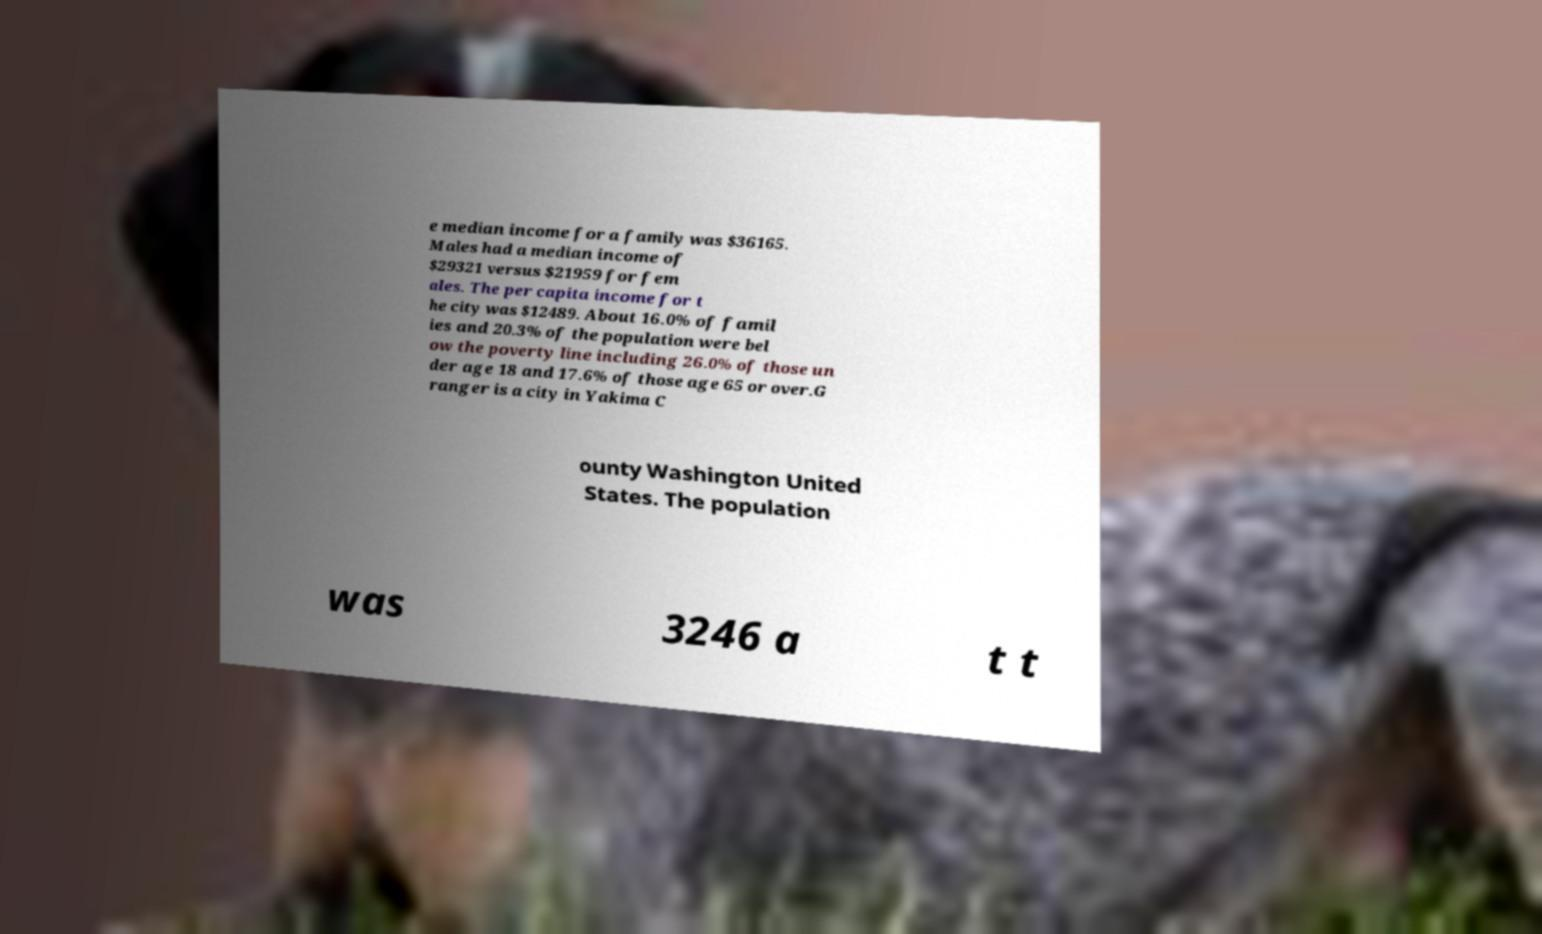Could you extract and type out the text from this image? e median income for a family was $36165. Males had a median income of $29321 versus $21959 for fem ales. The per capita income for t he city was $12489. About 16.0% of famil ies and 20.3% of the population were bel ow the poverty line including 26.0% of those un der age 18 and 17.6% of those age 65 or over.G ranger is a city in Yakima C ounty Washington United States. The population was 3246 a t t 